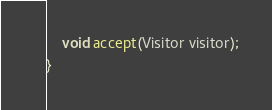Convert code to text. <code><loc_0><loc_0><loc_500><loc_500><_Java_>    void accept(Visitor visitor);
}
</code> 